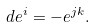Convert formula to latex. <formula><loc_0><loc_0><loc_500><loc_500>d e ^ { i } = - e ^ { j k } .</formula> 